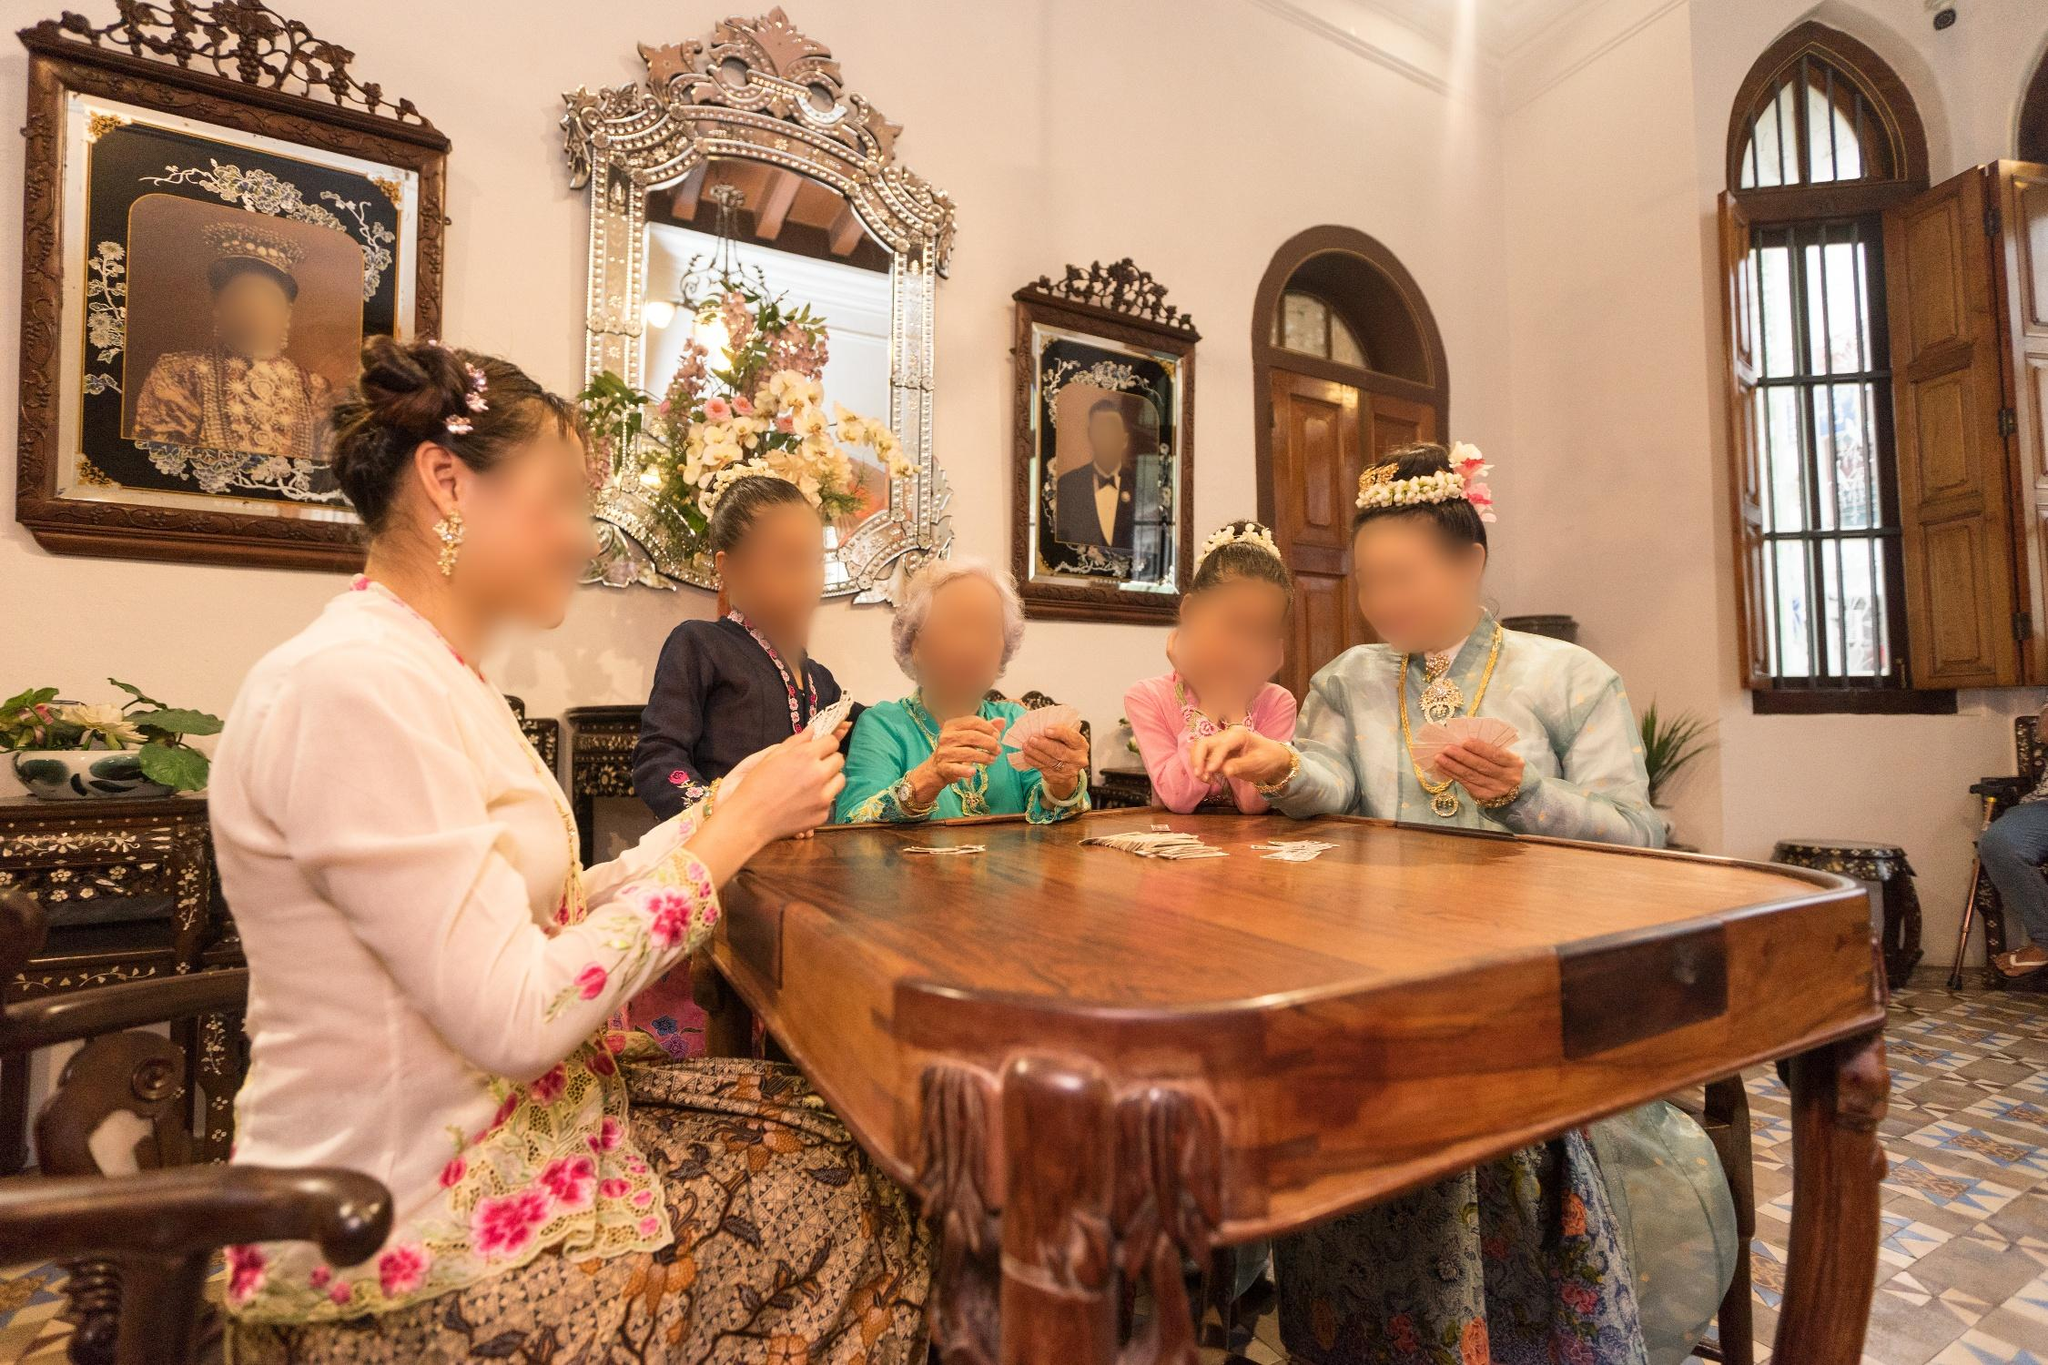Can you describe the type of occasion that might be taking place based on the attire and setting in the image? This scene likely depicts a cultural or familial gathering, possibly a traditional ceremony or celebration. The elaborate attire, including the detailed floral patterns and headpieces, along with the formal setting, suggests an event of significance, such as a cultural festival or a formal reception rooted in local customs. 